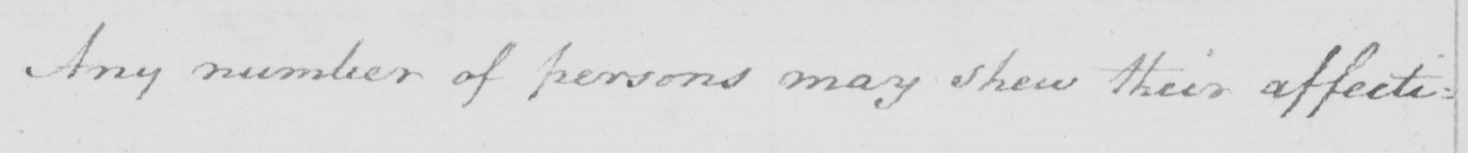Transcribe the text shown in this historical manuscript line. Any number of persons may shew the affecti= 